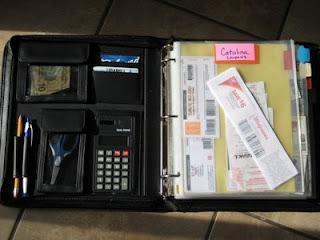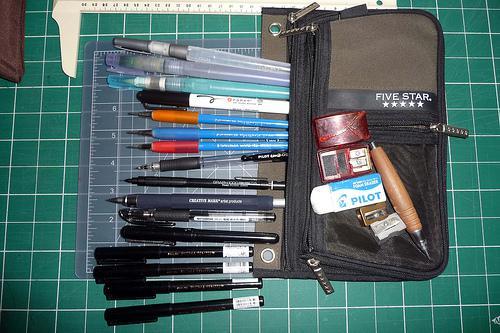The first image is the image on the left, the second image is the image on the right. Examine the images to the left and right. Is the description "The open notebooks contain multiple items; they are not empty." accurate? Answer yes or no. Yes. The first image is the image on the left, the second image is the image on the right. For the images shown, is this caption "The open trapper keeper is filled with paper and other items" true? Answer yes or no. Yes. 